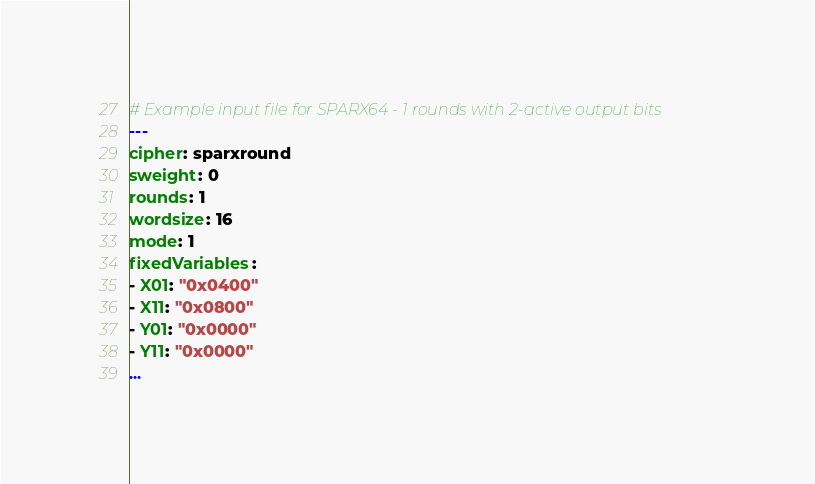<code> <loc_0><loc_0><loc_500><loc_500><_YAML_># Example input file for SPARX64 - 1 rounds with 2-active output bits
---
cipher: sparxround
sweight: 0
rounds: 1
wordsize: 16
mode: 1
fixedVariables:
- X01: "0x0400"
- X11: "0x0800"
- Y01: "0x0000"
- Y11: "0x0000"
...

</code> 